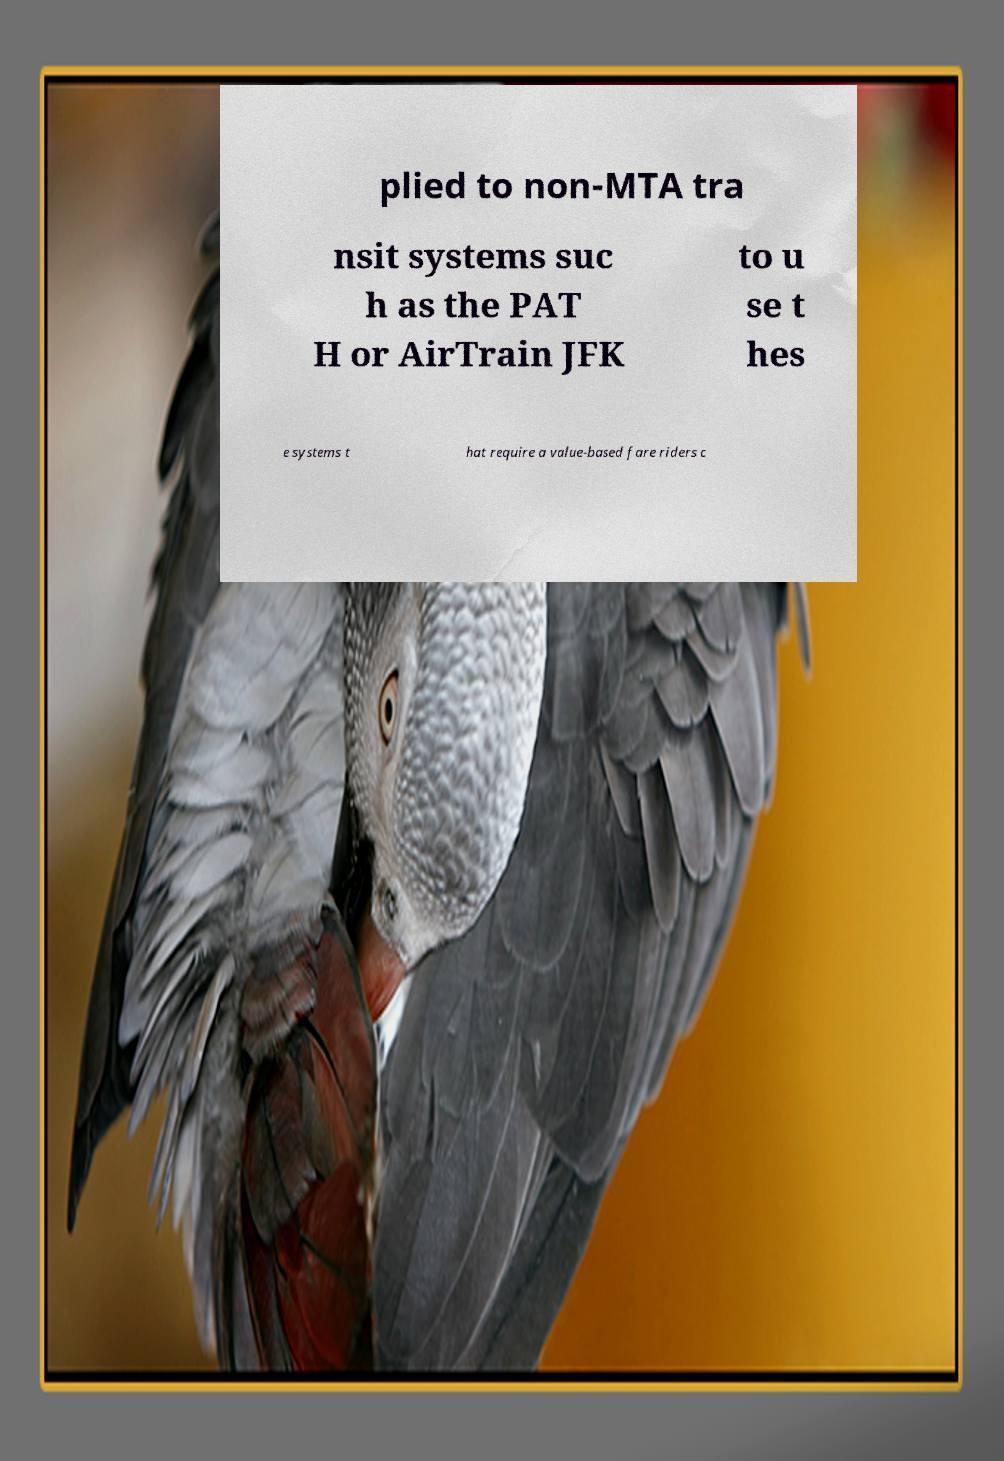Could you assist in decoding the text presented in this image and type it out clearly? plied to non-MTA tra nsit systems suc h as the PAT H or AirTrain JFK to u se t hes e systems t hat require a value-based fare riders c 